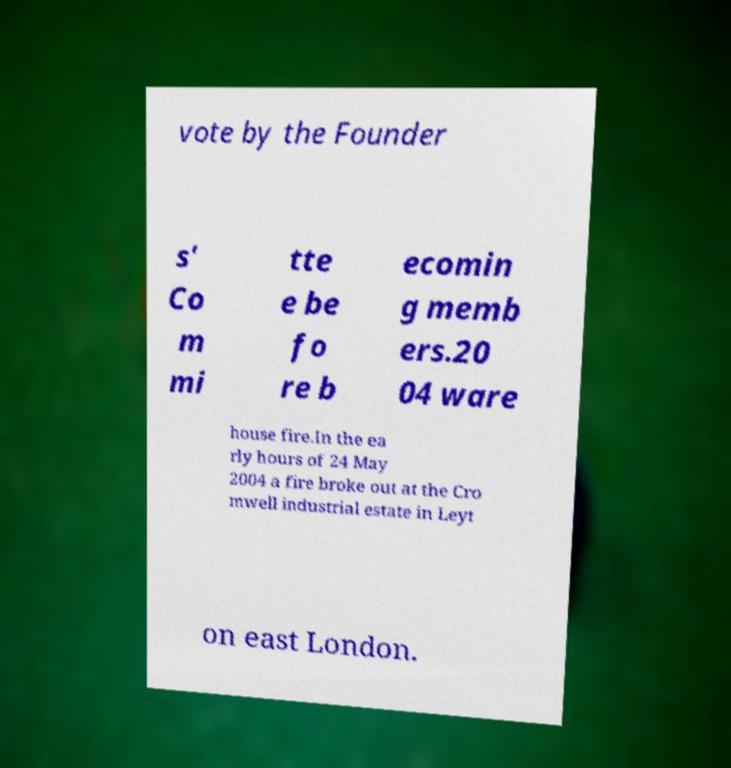Could you extract and type out the text from this image? vote by the Founder s' Co m mi tte e be fo re b ecomin g memb ers.20 04 ware house fire.In the ea rly hours of 24 May 2004 a fire broke out at the Cro mwell industrial estate in Leyt on east London. 